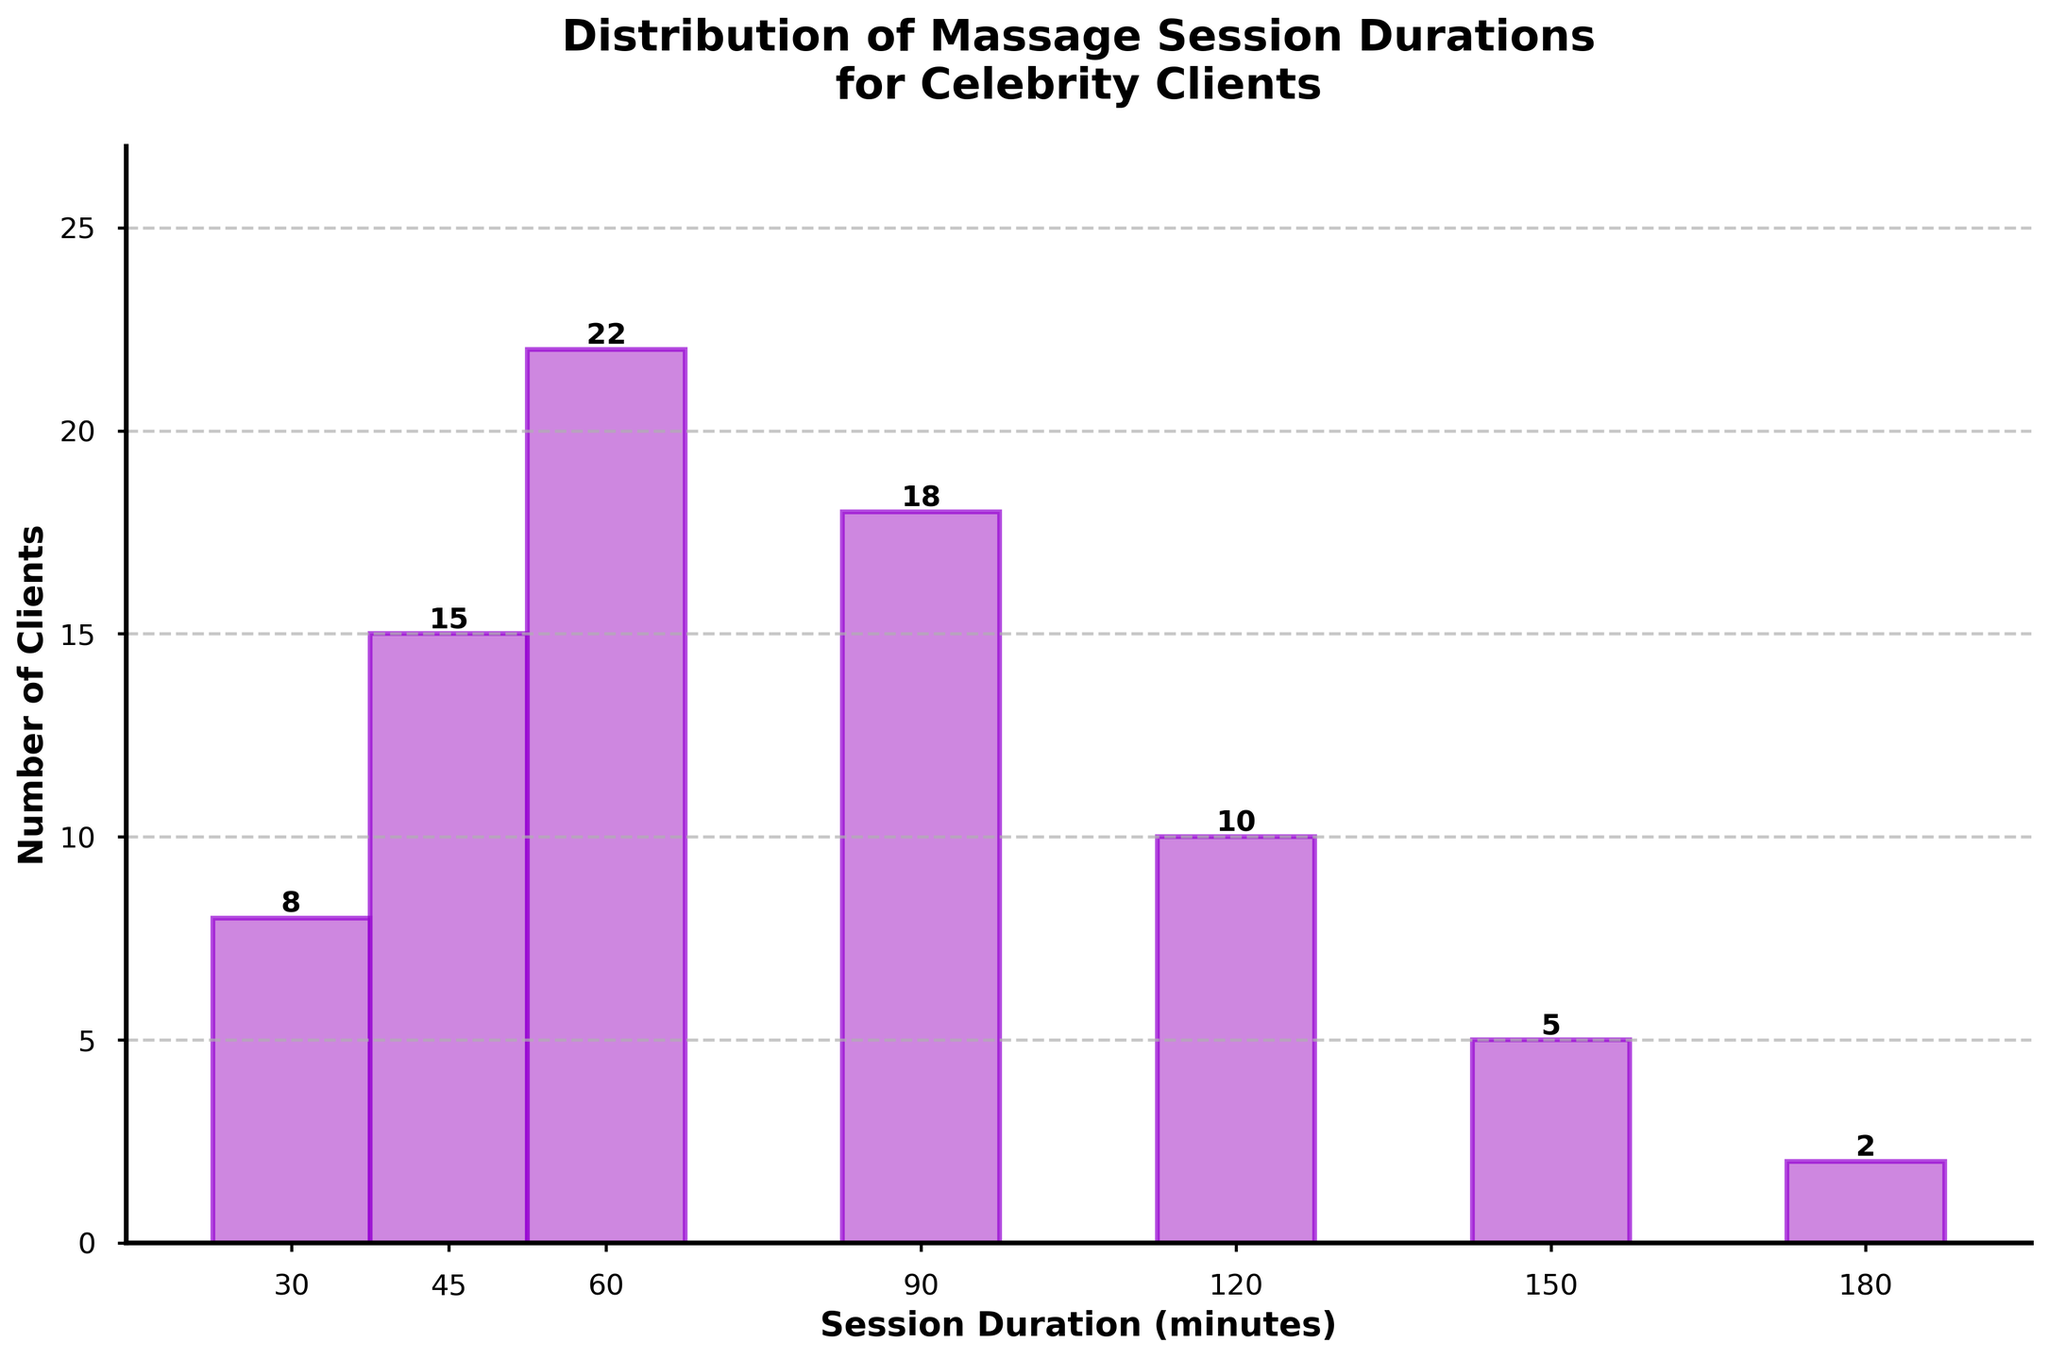Which session duration has the highest number of clients? The bar representing the session duration of 60 minutes has the highest height, indicating it has the highest number of clients.
Answer: 60 minutes How many clients prefer sessions of 90 minutes or longer? Sum the number of clients for session durations of 90 minutes, 120 minutes, 150 minutes, and 180 minutes. This is 18 + 10 + 5 + 2 = 35 clients.
Answer: 35 clients What is the difference in the number of clients between the 45-minute and 120-minute sessions? The number of clients for the 45-minute session is 15 and for the 120-minute session is 10. The difference is 15 - 10 = 5 clients.
Answer: 5 clients Which session durations have fewer clients than the 90-minute session? Compare the number of clients for each session duration with the number for the 90-minute session (18 clients). Durations with fewer clients are 30 minutes (8), 45 minutes (15), 120 minutes (10), 150 minutes (5), and 180 minutes (2).
Answer: 30, 45, 120, 150, 180 minutes Do more clients prefer 60-minute or 150-minute sessions? The bar for the 60-minute session is higher than for the 150-minute session. 60 minutes has 22 clients, while 150 minutes has 5 clients.
Answer: 60-minute sessions What percentage of clients prefer sessions shorter than 90 minutes? Sum the number of clients for sessions shorter than 90 minutes: 30 minutes (8), 45 minutes (15), and 60 minutes (22). The total number of clients is 8 + 15 + 22 = 45. Calculate the percentage: (45 / (8 + 15 + 22 + 18 + 10 + 5 + 2)) * 100 ≈ 52.94%.
Answer: ≈ 52.94% How many clients prefer sessions either of 30 minutes or 180 minutes? The number of clients for the 30-minute session is 8, and for the 180-minute session it is 2. The sum is 8 + 2 = 10 clients.
Answer: 10 clients Which session duration is preferred by fewer than 10 clients but more than 4 clients? The durations with fewer than 10 clients are 30 minutes (8), 120 minutes (10), 150 minutes (5), and 180 minutes (2). Only 30 minutes (8) and 150 minutes (5) meet the criteria.
Answer: 30 and 150 minutes 